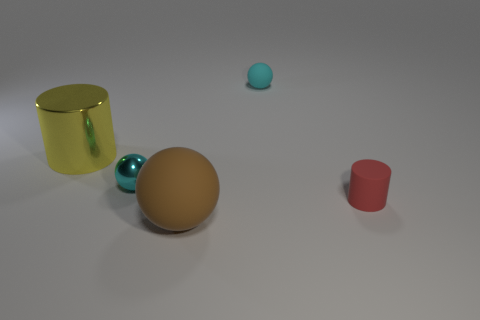There is a small matte thing behind the small red matte cylinder on the right side of the brown matte object; are there any large cylinders right of it?
Offer a very short reply. No. What number of spheres are small cyan matte things or large blue shiny things?
Offer a terse response. 1. There is a large rubber object; is its shape the same as the small cyan thing that is on the right side of the tiny cyan shiny object?
Provide a succinct answer. Yes. Are there fewer brown rubber objects on the right side of the red object than big brown blocks?
Your answer should be very brief. No. Are there any small red rubber cylinders in front of the red rubber cylinder?
Make the answer very short. No. Are there any cyan objects of the same shape as the large brown matte thing?
Offer a terse response. Yes. There is a cyan metallic thing that is the same size as the red matte cylinder; what is its shape?
Provide a succinct answer. Sphere. How many objects are tiny objects that are on the left side of the rubber cylinder or brown rubber spheres?
Offer a terse response. 3. Does the big cylinder have the same color as the large sphere?
Keep it short and to the point. No. What is the size of the cyan sphere to the left of the brown object?
Your answer should be compact. Small. 